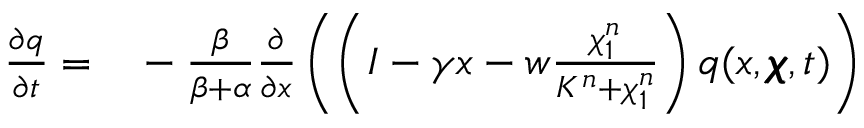Convert formula to latex. <formula><loc_0><loc_0><loc_500><loc_500>\begin{array} { r l } { \frac { \partial q } { \partial t } = } & - \frac { \beta } { \beta + \alpha } \frac { \partial } { \partial x } \left ( \left ( I - \gamma x - w \frac { \chi _ { 1 } ^ { n } } { K ^ { n } + \chi _ { 1 } ^ { n } } \right ) q ( x , \pm b { \chi } , t ) \right ) } \end{array}</formula> 